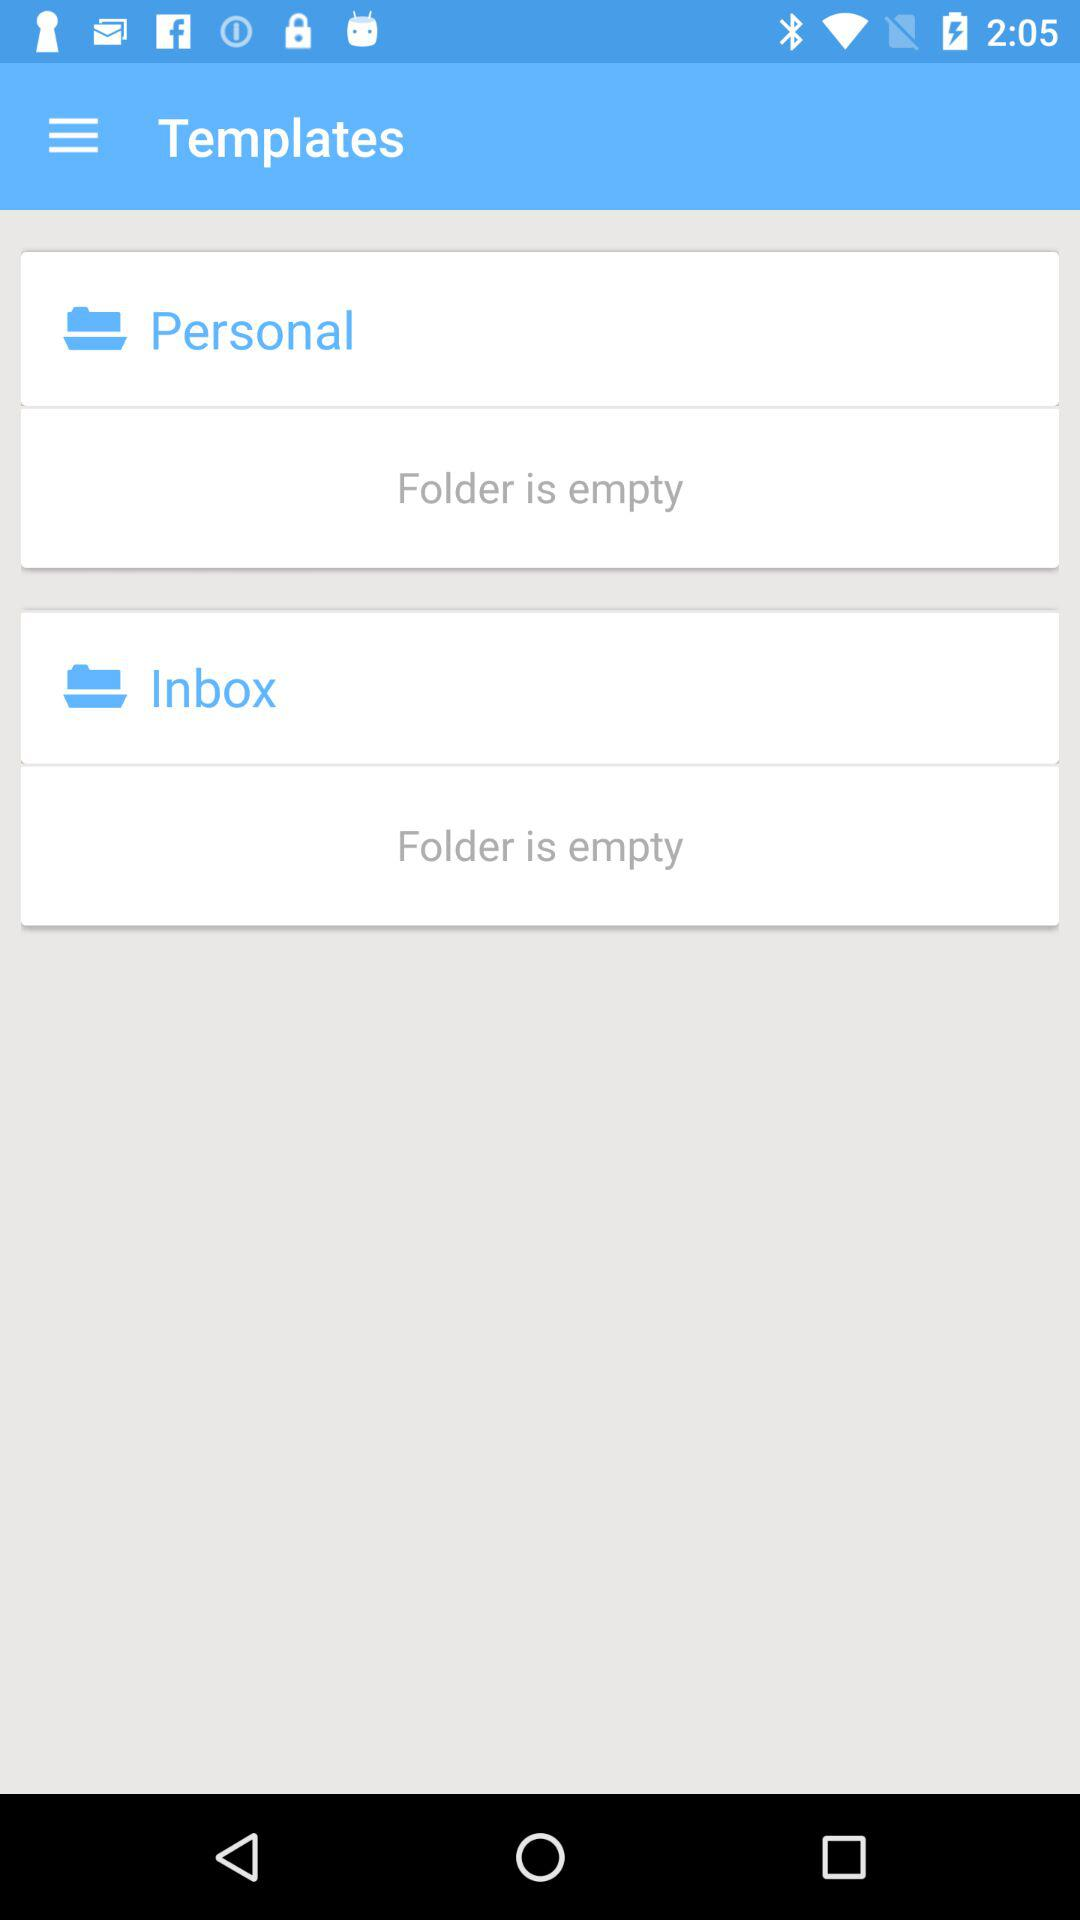How many folders are empty?
Answer the question using a single word or phrase. 2 